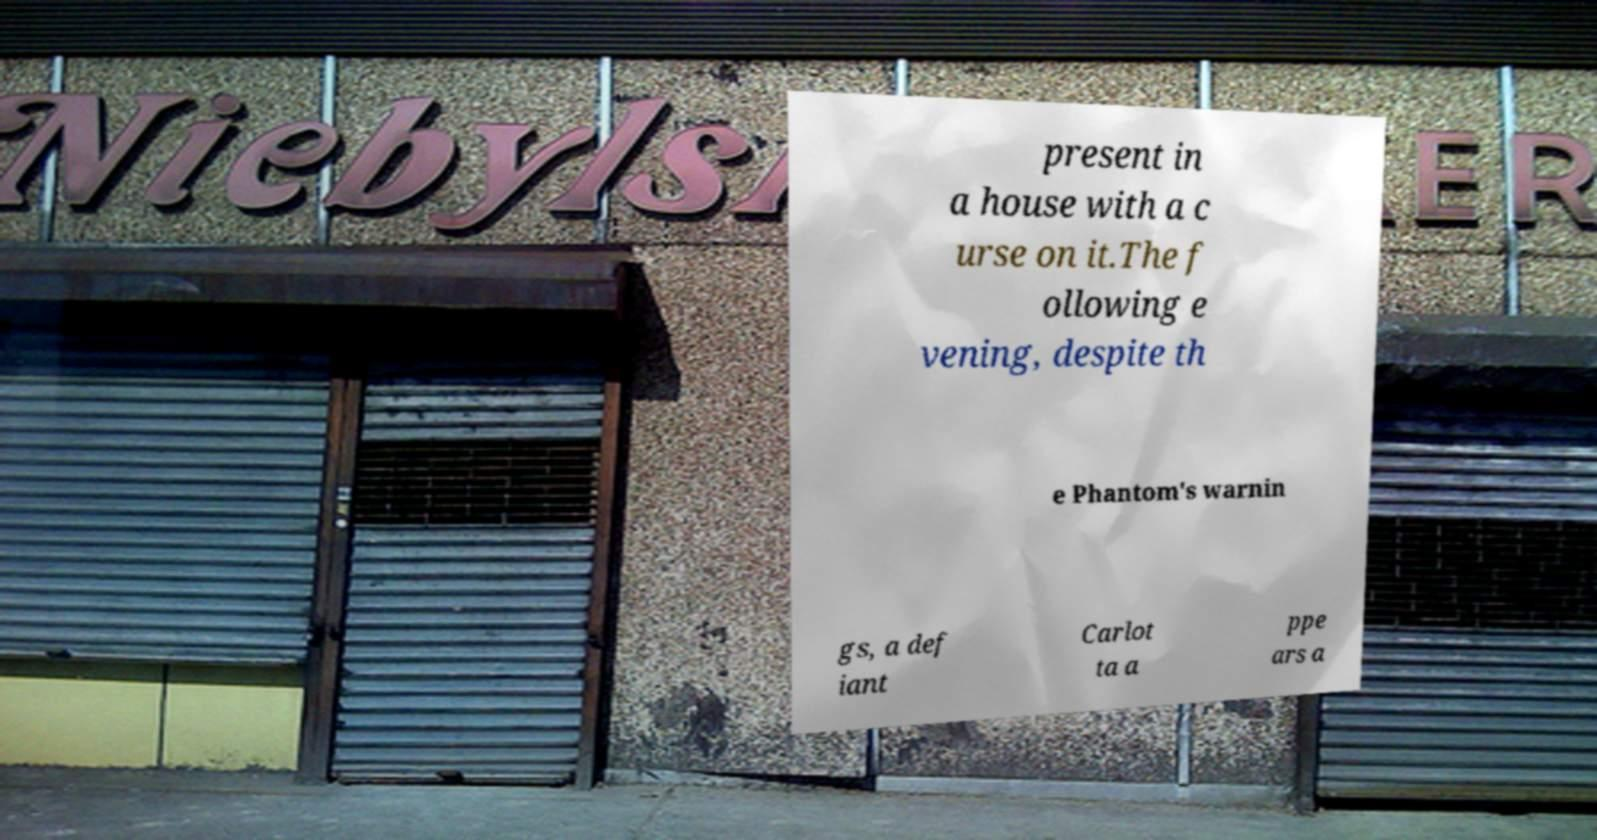There's text embedded in this image that I need extracted. Can you transcribe it verbatim? present in a house with a c urse on it.The f ollowing e vening, despite th e Phantom's warnin gs, a def iant Carlot ta a ppe ars a 